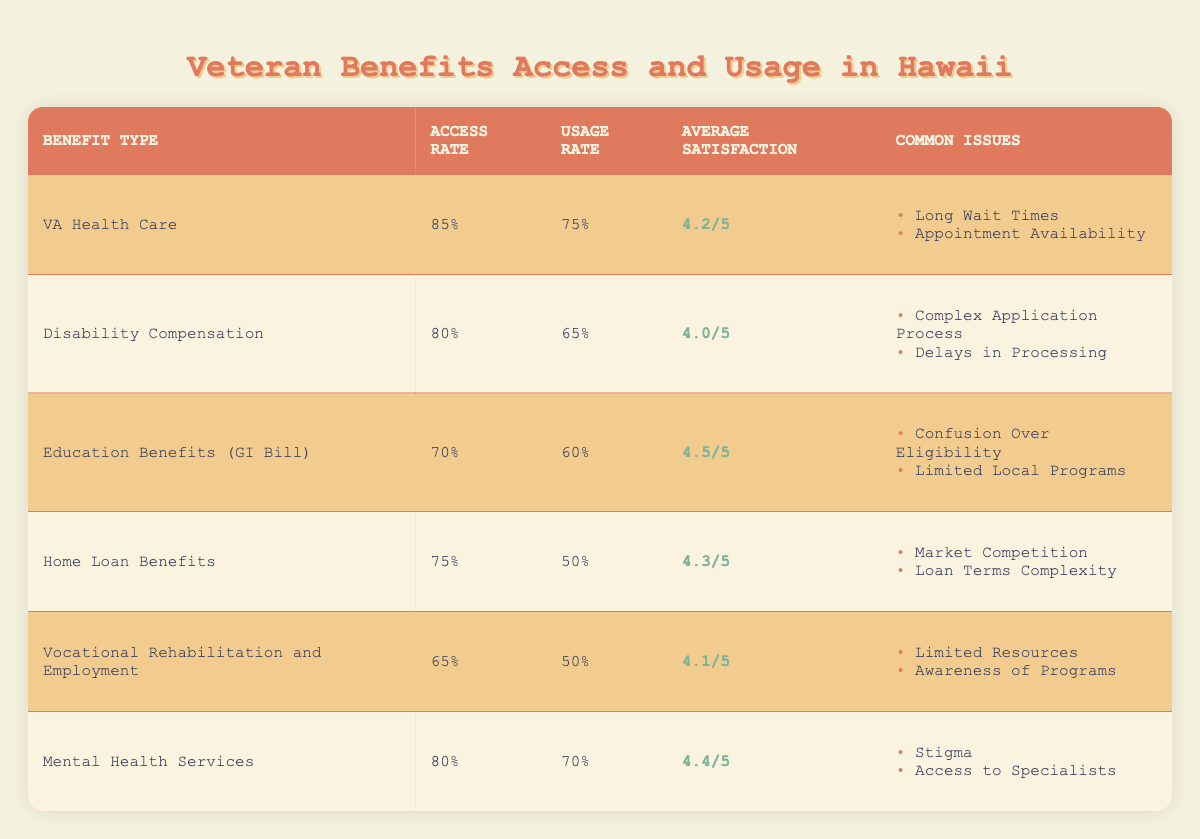What is the access rate for VA Health Care? The access rate for each benefit type is listed in the corresponding row. For VA Health Care, the access rate is 85%.
Answer: 85% What is the usage rate for Education Benefits (GI Bill)? The usage rate for each benefit type is presented in the table. For Education Benefits (GI Bill), the usage rate is 60%.
Answer: 60% Are more veterans accessing Mental Health Services than Home Loan Benefits? The access rates are 80% for Mental Health Services and 75% for Home Loan Benefits. Since 80% is greater than 75%, more veterans are accessing Mental Health Services.
Answer: Yes What is the average satisfaction score among all benefits listed? The satisfaction scores are 4.2, 4.0, 4.5, 4.3, 4.1, and 4.4. Summing these gives 4.2 + 4.0 + 4.5 + 4.3 + 4.1 + 4.4 = 25.5. There are six scores, so the average is 25.5 / 6 ≈ 4.25.
Answer: 4.25 What common issues are associated with Disability Compensation? The common issues for Disability Compensation are listed in the corresponding row of the table. These issues are "Complex Application Process" and "Delays in Processing."
Answer: Complex Application Process, Delays in Processing How does the access rate for Vocational Rehabilitation compare to Mental Health Services? The access rates are 65% for Vocational Rehabilitation and 80% for Mental Health Services. Since 65% is less than 80%, Vocational Rehabilitation has a lower access rate.
Answer: Lower What percentage of veterans use Home Loan Benefits? The usage rate for Home Loan Benefits is specifically mentioned in its corresponding row. This value is 50%.
Answer: 50% Is the average satisfaction score for Education Benefits higher than for Vocational Rehabilitation? The average satisfaction score for Education Benefits is 4.5 and for Vocational Rehabilitation is 4.1. Since 4.5 is greater than 4.1, Education Benefits has a higher average satisfaction score.
Answer: Yes Determine the difference in usage rates between VA Health Care and Disability Compensation. The usage rates are 75% for VA Health Care and 65% for Disability Compensation. The difference is 75% - 65% = 10%.
Answer: 10% 